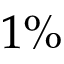<formula> <loc_0><loc_0><loc_500><loc_500>1 \%</formula> 